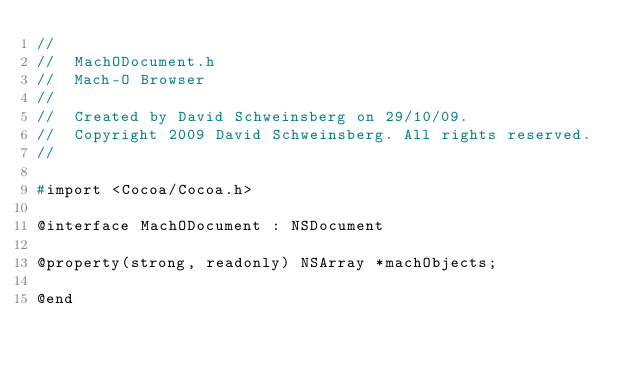Convert code to text. <code><loc_0><loc_0><loc_500><loc_500><_C_>//
//  MachODocument.h
//  Mach-O Browser
//
//  Created by David Schweinsberg on 29/10/09.
//  Copyright 2009 David Schweinsberg. All rights reserved.
//

#import <Cocoa/Cocoa.h>

@interface MachODocument : NSDocument

@property(strong, readonly) NSArray *machObjects;

@end
</code> 